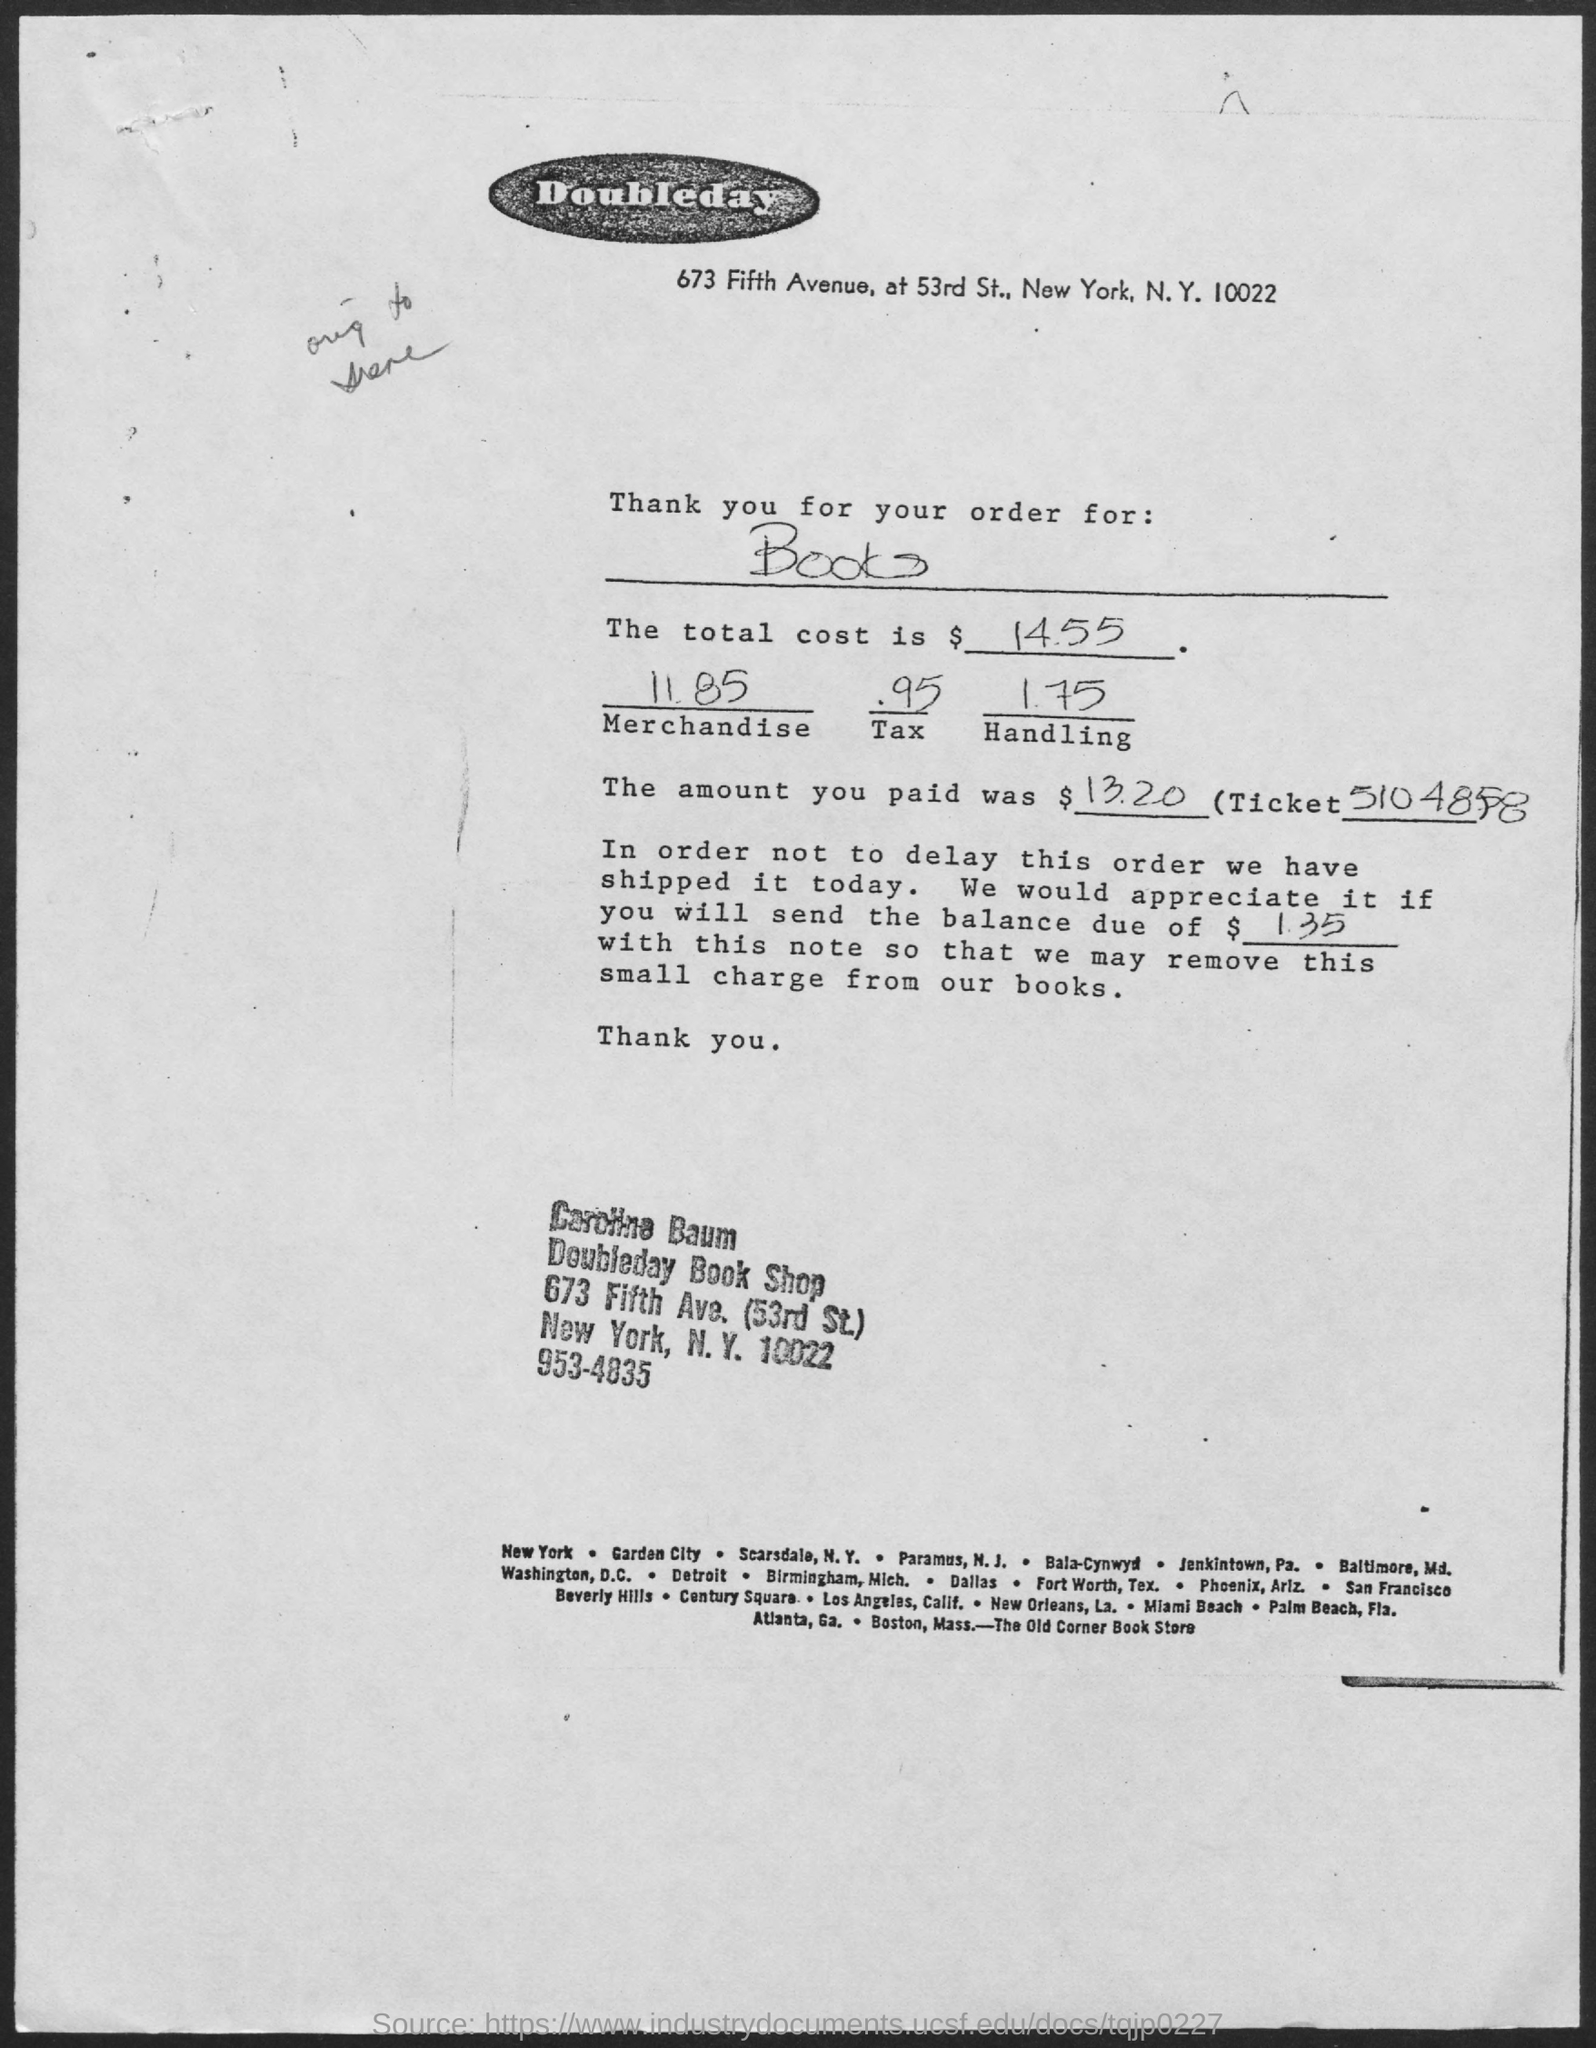Specify some key components in this picture. The ticket number is 5104858... The cost of handling is 1.75... The total cost is $14.55. The amount paid is $13.20. The tax is 0.95. 